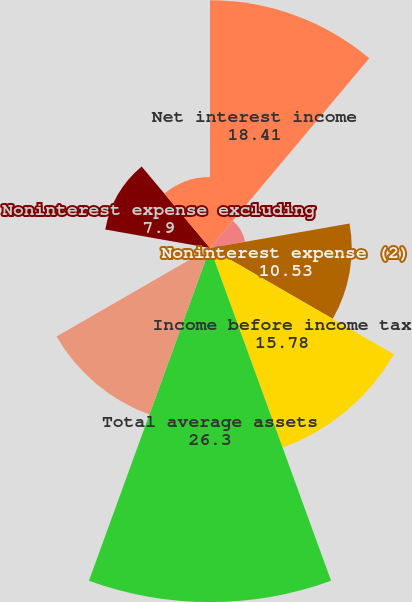Convert chart to OTSL. <chart><loc_0><loc_0><loc_500><loc_500><pie_chart><fcel>Net interest income<fcel>Noninterest income<fcel>Noninterest expense (2)<fcel>Income before income tax<fcel>Total average assets<fcel>Net interest income (loss)<fcel>Noninterest income (loss)<fcel>Noninterest expense excluding<fcel>Income (loss) before income<nl><fcel>18.41%<fcel>2.64%<fcel>10.53%<fcel>15.78%<fcel>26.3%<fcel>13.16%<fcel>0.01%<fcel>7.9%<fcel>5.27%<nl></chart> 